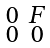Convert formula to latex. <formula><loc_0><loc_0><loc_500><loc_500>\begin{smallmatrix} 0 & F \\ 0 & 0 \end{smallmatrix}</formula> 